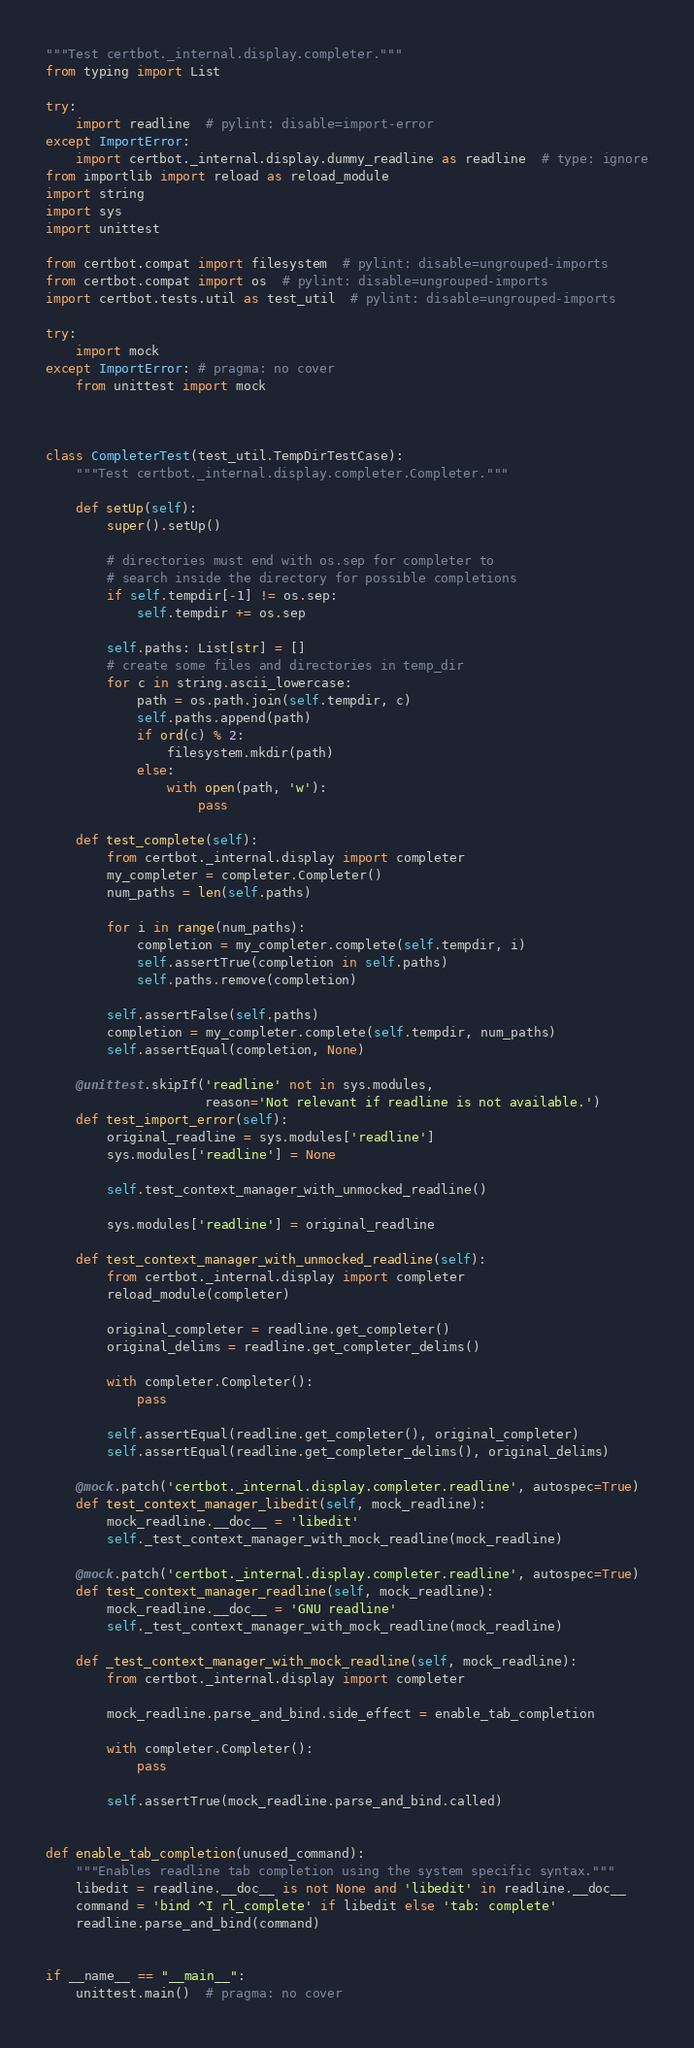Convert code to text. <code><loc_0><loc_0><loc_500><loc_500><_Python_>"""Test certbot._internal.display.completer."""
from typing import List

try:
    import readline  # pylint: disable=import-error
except ImportError:
    import certbot._internal.display.dummy_readline as readline  # type: ignore
from importlib import reload as reload_module
import string
import sys
import unittest

from certbot.compat import filesystem  # pylint: disable=ungrouped-imports
from certbot.compat import os  # pylint: disable=ungrouped-imports
import certbot.tests.util as test_util  # pylint: disable=ungrouped-imports

try:
    import mock
except ImportError: # pragma: no cover
    from unittest import mock



class CompleterTest(test_util.TempDirTestCase):
    """Test certbot._internal.display.completer.Completer."""

    def setUp(self):
        super().setUp()

        # directories must end with os.sep for completer to
        # search inside the directory for possible completions
        if self.tempdir[-1] != os.sep:
            self.tempdir += os.sep

        self.paths: List[str] = []
        # create some files and directories in temp_dir
        for c in string.ascii_lowercase:
            path = os.path.join(self.tempdir, c)
            self.paths.append(path)
            if ord(c) % 2:
                filesystem.mkdir(path)
            else:
                with open(path, 'w'):
                    pass

    def test_complete(self):
        from certbot._internal.display import completer
        my_completer = completer.Completer()
        num_paths = len(self.paths)

        for i in range(num_paths):
            completion = my_completer.complete(self.tempdir, i)
            self.assertTrue(completion in self.paths)
            self.paths.remove(completion)

        self.assertFalse(self.paths)
        completion = my_completer.complete(self.tempdir, num_paths)
        self.assertEqual(completion, None)

    @unittest.skipIf('readline' not in sys.modules,
                     reason='Not relevant if readline is not available.')
    def test_import_error(self):
        original_readline = sys.modules['readline']
        sys.modules['readline'] = None

        self.test_context_manager_with_unmocked_readline()

        sys.modules['readline'] = original_readline

    def test_context_manager_with_unmocked_readline(self):
        from certbot._internal.display import completer
        reload_module(completer)

        original_completer = readline.get_completer()
        original_delims = readline.get_completer_delims()

        with completer.Completer():
            pass

        self.assertEqual(readline.get_completer(), original_completer)
        self.assertEqual(readline.get_completer_delims(), original_delims)

    @mock.patch('certbot._internal.display.completer.readline', autospec=True)
    def test_context_manager_libedit(self, mock_readline):
        mock_readline.__doc__ = 'libedit'
        self._test_context_manager_with_mock_readline(mock_readline)

    @mock.patch('certbot._internal.display.completer.readline', autospec=True)
    def test_context_manager_readline(self, mock_readline):
        mock_readline.__doc__ = 'GNU readline'
        self._test_context_manager_with_mock_readline(mock_readline)

    def _test_context_manager_with_mock_readline(self, mock_readline):
        from certbot._internal.display import completer

        mock_readline.parse_and_bind.side_effect = enable_tab_completion

        with completer.Completer():
            pass

        self.assertTrue(mock_readline.parse_and_bind.called)


def enable_tab_completion(unused_command):
    """Enables readline tab completion using the system specific syntax."""
    libedit = readline.__doc__ is not None and 'libedit' in readline.__doc__
    command = 'bind ^I rl_complete' if libedit else 'tab: complete'
    readline.parse_and_bind(command)


if __name__ == "__main__":
    unittest.main()  # pragma: no cover
</code> 